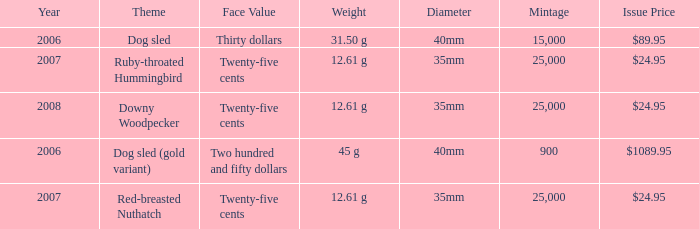What is the Theme of the coin with an Issue Price of $89.95? Dog sled. 